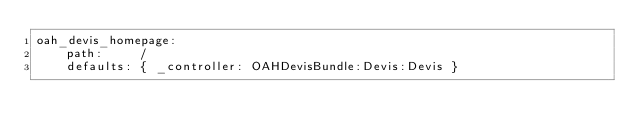Convert code to text. <code><loc_0><loc_0><loc_500><loc_500><_YAML_>oah_devis_homepage:
    path:     /
    defaults: { _controller: OAHDevisBundle:Devis:Devis }
</code> 